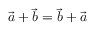Convert formula to latex. <formula><loc_0><loc_0><loc_500><loc_500>{ \vec { a } } + { \vec { b } } = { \vec { b } } + { \vec { a } }</formula> 